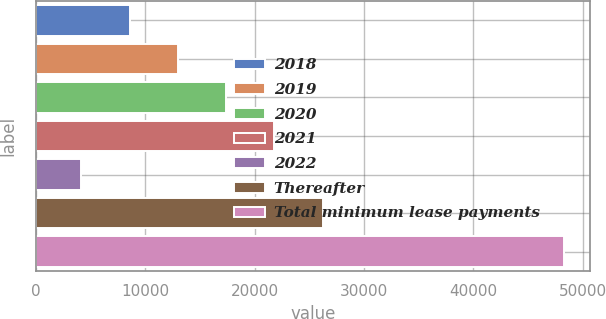<chart> <loc_0><loc_0><loc_500><loc_500><bar_chart><fcel>2018<fcel>2019<fcel>2020<fcel>2021<fcel>2022<fcel>Thereafter<fcel>Total minimum lease payments<nl><fcel>8581.3<fcel>12990.6<fcel>17399.9<fcel>21809.2<fcel>4172<fcel>26218.5<fcel>48265<nl></chart> 